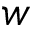Convert formula to latex. <formula><loc_0><loc_0><loc_500><loc_500>w</formula> 